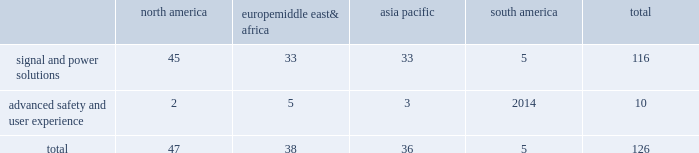Adequacy of our provision for income taxes , we regularly assess the likelihood of adverse outcomes resulting from tax examinations .
While it is often difficult to predict the final outcome or the timing of the resolution of a tax examination , our reserves for uncertain tax benefits reflect the outcome of tax positions that are more likely than not to occur .
While we believe that we have complied with all applicable tax laws , there can be no assurance that a taxing authority will not have a different interpretation of the law and assess us with additional taxes .
Should additional taxes be assessed , this may result in a material adverse effect on our results of operations and financial condition .
Item 1b .
Unresolved staff comments we have no unresolved sec staff comments to report .
Item 2 .
Properties as of december 31 , 2018 , we owned or leased 126 major manufacturing sites and 15 major technical centers .
A manufacturing site may include multiple plants and may be wholly or partially owned or leased .
We also have many smaller manufacturing sites , sales offices , warehouses , engineering centers , joint ventures and other investments strategically located throughout the world .
We have a presence in 44 countries .
The table shows the regional distribution of our major manufacturing sites by the operating segment that uses such facilities : north america europe , middle east & africa asia pacific south america total .
In addition to these manufacturing sites , we had 15 major technical centers : eight in north america ; two in europe , middle east and africa ; and five in asia pacific .
Of our 126 major manufacturing sites and 15 major technical centers , which include facilities owned or leased by our consolidated subsidiaries , 61 are primarily owned and 80 are primarily leased .
We frequently review our real estate portfolio and develop footprint strategies to support our customers 2019 global plans , while at the same time supporting our technical needs and controlling operating expenses .
We believe our evolving portfolio will meet current and anticipated future needs .
Item 3 .
Legal proceedings we are from time to time subject to various actions , claims , suits , government investigations , and other proceedings incidental to our business , including those arising out of alleged defects , breach of contracts , competition and antitrust matters , product warranties , intellectual property matters , personal injury claims and employment-related matters .
It is our opinion that the outcome of such matters will not have a material adverse impact on our consolidated financial position , results of operations , or cash flows .
With respect to warranty matters , although we cannot ensure that the future costs of warranty claims by customers will not be material , we believe our established reserves are adequate to cover potential warranty settlements .
However , the final amounts required to resolve these matters could differ materially from our recorded estimates .
Brazil matters aptiv conducts business operations in brazil that are subject to the brazilian federal labor , social security , environmental , tax and customs laws , as well as a variety of state and local laws .
While aptiv believes it complies with such laws , they are complex , subject to varying interpretations , and the company is often engaged in litigation with government agencies regarding the application of these laws to particular circumstances .
As of december 31 , 2018 , the majority of claims asserted against aptiv in brazil relate to such litigation .
The remaining claims in brazil relate to commercial and labor litigation with private parties .
As of december 31 , 2018 , claims totaling approximately $ 145 million ( using december 31 , 2018 foreign currency rates ) have been asserted against aptiv in brazil .
As of december 31 , 2018 , the company maintains accruals for these asserted claims of $ 30 million ( using december 31 , 2018 foreign currency rates ) .
The amounts accrued represent claims that are deemed probable of loss and are reasonably estimable based on the company 2019s analyses and assessment of the asserted claims and prior experience with similar matters .
While the company believes its accruals are adequate , the final amounts required to resolve these matters could differ materially from the company 2019s recorded estimates and aptiv 2019s results of .
What percentage of major manufacturing sites are based in europe middle east& africa? 
Computations: (38 / 126)
Answer: 0.30159. Adequacy of our provision for income taxes , we regularly assess the likelihood of adverse outcomes resulting from tax examinations .
While it is often difficult to predict the final outcome or the timing of the resolution of a tax examination , our reserves for uncertain tax benefits reflect the outcome of tax positions that are more likely than not to occur .
While we believe that we have complied with all applicable tax laws , there can be no assurance that a taxing authority will not have a different interpretation of the law and assess us with additional taxes .
Should additional taxes be assessed , this may result in a material adverse effect on our results of operations and financial condition .
Item 1b .
Unresolved staff comments we have no unresolved sec staff comments to report .
Item 2 .
Properties as of december 31 , 2018 , we owned or leased 126 major manufacturing sites and 15 major technical centers .
A manufacturing site may include multiple plants and may be wholly or partially owned or leased .
We also have many smaller manufacturing sites , sales offices , warehouses , engineering centers , joint ventures and other investments strategically located throughout the world .
We have a presence in 44 countries .
The table shows the regional distribution of our major manufacturing sites by the operating segment that uses such facilities : north america europe , middle east & africa asia pacific south america total .
In addition to these manufacturing sites , we had 15 major technical centers : eight in north america ; two in europe , middle east and africa ; and five in asia pacific .
Of our 126 major manufacturing sites and 15 major technical centers , which include facilities owned or leased by our consolidated subsidiaries , 61 are primarily owned and 80 are primarily leased .
We frequently review our real estate portfolio and develop footprint strategies to support our customers 2019 global plans , while at the same time supporting our technical needs and controlling operating expenses .
We believe our evolving portfolio will meet current and anticipated future needs .
Item 3 .
Legal proceedings we are from time to time subject to various actions , claims , suits , government investigations , and other proceedings incidental to our business , including those arising out of alleged defects , breach of contracts , competition and antitrust matters , product warranties , intellectual property matters , personal injury claims and employment-related matters .
It is our opinion that the outcome of such matters will not have a material adverse impact on our consolidated financial position , results of operations , or cash flows .
With respect to warranty matters , although we cannot ensure that the future costs of warranty claims by customers will not be material , we believe our established reserves are adequate to cover potential warranty settlements .
However , the final amounts required to resolve these matters could differ materially from our recorded estimates .
Brazil matters aptiv conducts business operations in brazil that are subject to the brazilian federal labor , social security , environmental , tax and customs laws , as well as a variety of state and local laws .
While aptiv believes it complies with such laws , they are complex , subject to varying interpretations , and the company is often engaged in litigation with government agencies regarding the application of these laws to particular circumstances .
As of december 31 , 2018 , the majority of claims asserted against aptiv in brazil relate to such litigation .
The remaining claims in brazil relate to commercial and labor litigation with private parties .
As of december 31 , 2018 , claims totaling approximately $ 145 million ( using december 31 , 2018 foreign currency rates ) have been asserted against aptiv in brazil .
As of december 31 , 2018 , the company maintains accruals for these asserted claims of $ 30 million ( using december 31 , 2018 foreign currency rates ) .
The amounts accrued represent claims that are deemed probable of loss and are reasonably estimable based on the company 2019s analyses and assessment of the asserted claims and prior experience with similar matters .
While the company believes its accruals are adequate , the final amounts required to resolve these matters could differ materially from the company 2019s recorded estimates and aptiv 2019s results of .
What percentage of major manufacturing sites are based in asia pacific? 
Computations: (36 / 126)
Answer: 0.28571. Adequacy of our provision for income taxes , we regularly assess the likelihood of adverse outcomes resulting from tax examinations .
While it is often difficult to predict the final outcome or the timing of the resolution of a tax examination , our reserves for uncertain tax benefits reflect the outcome of tax positions that are more likely than not to occur .
While we believe that we have complied with all applicable tax laws , there can be no assurance that a taxing authority will not have a different interpretation of the law and assess us with additional taxes .
Should additional taxes be assessed , this may result in a material adverse effect on our results of operations and financial condition .
Item 1b .
Unresolved staff comments we have no unresolved sec staff comments to report .
Item 2 .
Properties as of december 31 , 2018 , we owned or leased 126 major manufacturing sites and 15 major technical centers .
A manufacturing site may include multiple plants and may be wholly or partially owned or leased .
We also have many smaller manufacturing sites , sales offices , warehouses , engineering centers , joint ventures and other investments strategically located throughout the world .
We have a presence in 44 countries .
The table shows the regional distribution of our major manufacturing sites by the operating segment that uses such facilities : north america europe , middle east & africa asia pacific south america total .
In addition to these manufacturing sites , we had 15 major technical centers : eight in north america ; two in europe , middle east and africa ; and five in asia pacific .
Of our 126 major manufacturing sites and 15 major technical centers , which include facilities owned or leased by our consolidated subsidiaries , 61 are primarily owned and 80 are primarily leased .
We frequently review our real estate portfolio and develop footprint strategies to support our customers 2019 global plans , while at the same time supporting our technical needs and controlling operating expenses .
We believe our evolving portfolio will meet current and anticipated future needs .
Item 3 .
Legal proceedings we are from time to time subject to various actions , claims , suits , government investigations , and other proceedings incidental to our business , including those arising out of alleged defects , breach of contracts , competition and antitrust matters , product warranties , intellectual property matters , personal injury claims and employment-related matters .
It is our opinion that the outcome of such matters will not have a material adverse impact on our consolidated financial position , results of operations , or cash flows .
With respect to warranty matters , although we cannot ensure that the future costs of warranty claims by customers will not be material , we believe our established reserves are adequate to cover potential warranty settlements .
However , the final amounts required to resolve these matters could differ materially from our recorded estimates .
Brazil matters aptiv conducts business operations in brazil that are subject to the brazilian federal labor , social security , environmental , tax and customs laws , as well as a variety of state and local laws .
While aptiv believes it complies with such laws , they are complex , subject to varying interpretations , and the company is often engaged in litigation with government agencies regarding the application of these laws to particular circumstances .
As of december 31 , 2018 , the majority of claims asserted against aptiv in brazil relate to such litigation .
The remaining claims in brazil relate to commercial and labor litigation with private parties .
As of december 31 , 2018 , claims totaling approximately $ 145 million ( using december 31 , 2018 foreign currency rates ) have been asserted against aptiv in brazil .
As of december 31 , 2018 , the company maintains accruals for these asserted claims of $ 30 million ( using december 31 , 2018 foreign currency rates ) .
The amounts accrued represent claims that are deemed probable of loss and are reasonably estimable based on the company 2019s analyses and assessment of the asserted claims and prior experience with similar matters .
While the company believes its accruals are adequate , the final amounts required to resolve these matters could differ materially from the company 2019s recorded estimates and aptiv 2019s results of .
What is the percentage of north america's signal and power solutions sites among all signal and power solutions sites? 
Rationale: it is the number of sites in north america divided by the total sites , then turned into a percentage .
Computations: (45 / 116)
Answer: 0.38793. 